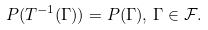<formula> <loc_0><loc_0><loc_500><loc_500>P ( T ^ { - 1 } ( \Gamma ) ) = P ( \Gamma ) , \, \Gamma \in \mathcal { F } .</formula> 